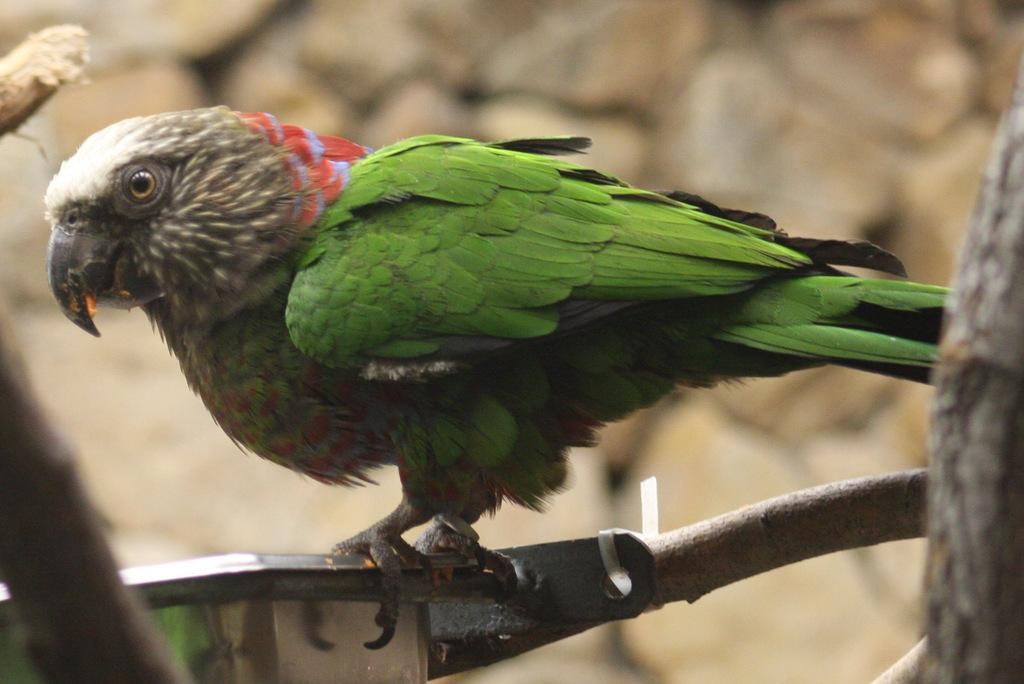What type of animal can be seen in the image? There is a bird in the image. Where is the bird located in the image? The bird is standing on a stem. Is there any sign of a nosebleed on the bird in the image? There is no indication of a nosebleed or any other medical condition on the bird in the image. Did the stem the bird is standing on cause an earthquake in the image? There is no indication of an earthquake or any other natural disaster in the image. 